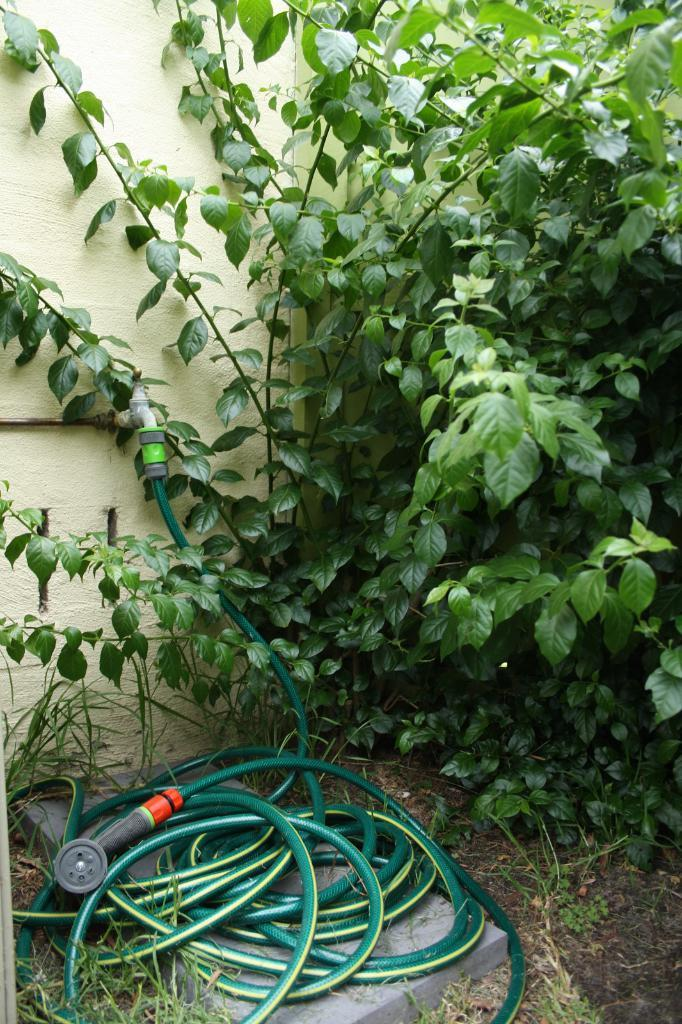What is the main object in the center of the image? There is a tap in the center of the image. What else can be seen in the image besides the tap? There is a pipe and a plant visible in the image. What is the background of the image? There is a wall in the background of the image. What type of vegetation is at the bottom of the image? There is grass at the bottom of the image. What type of instrument is being played by the turkey in the image? There is no turkey or instrument present in the image. 